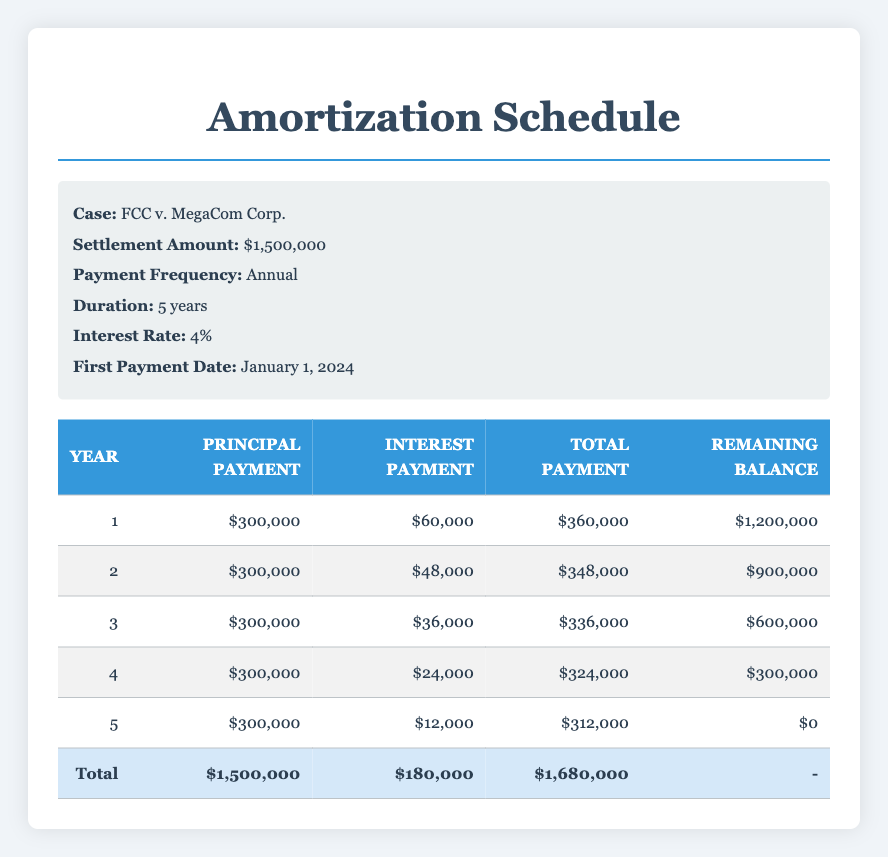What is the total amount of principal payments made over the 5 years? By adding up the principal payments for each year: 300,000 (year 1) + 300,000 (year 2) + 300,000 (year 3) + 300,000 (year 4) + 300,000 (year 5) = 1,500,000
Answer: 1,500,000 What is the interest payment in the final year? The interest payment for year 5 is listed as 12,000 in the table.
Answer: 12,000 Is the total payment in the first year greater than in the second year? In year 1, the total payment is 360,000, while in year 2 it is 348,000. Since 360,000 is greater than 348,000, the statement is true.
Answer: Yes What is the remaining balance after the third year's payment? In year 3, the remaining balance is shown as 600,000.
Answer: 600,000 What is the average interest payment over the 5-year period? The total interest payments are 60,000 (year 1) + 48,000 (year 2) + 36,000 (year 3) + 24,000 (year 4) + 12,000 (year 5) = 180,000. Divide by 5 years: 180,000 / 5 = 36,000.
Answer: 36,000 How much did the total payments decrease from the first year to the last year? The total payments are 360,000 in year 1 and 312,000 in year 5. The decrease is 360,000 - 312,000 = 48,000.
Answer: 48,000 Are all remaining balances after the payments made in each year reduced to zero by the end of year 5? The remaining balance after year 5 is zero, confirming that the settlement is fully paid off.
Answer: Yes What is the interest payment for the second year compared to the first year? The interest payment is 48,000 for the second year and 60,000 for the first year. Since 48,000 is less than 60,000, the second year payment is lower.
Answer: Lower What is the total amount paid in year 4? The total payment for year 4 is listed as 324,000 in the table.
Answer: 324,000 